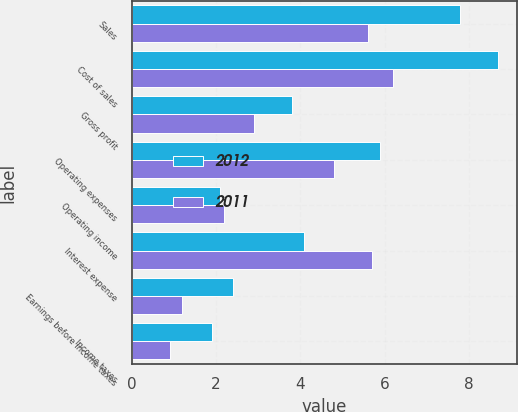Convert chart. <chart><loc_0><loc_0><loc_500><loc_500><stacked_bar_chart><ecel><fcel>Sales<fcel>Cost of sales<fcel>Gross profit<fcel>Operating expenses<fcel>Operating income<fcel>Interest expense<fcel>Earnings before income taxes<fcel>Income taxes<nl><fcel>2012<fcel>7.8<fcel>8.7<fcel>3.8<fcel>5.9<fcel>2.1<fcel>4.1<fcel>2.4<fcel>1.9<nl><fcel>2011<fcel>5.6<fcel>6.2<fcel>2.9<fcel>4.8<fcel>2.2<fcel>5.7<fcel>1.2<fcel>0.9<nl></chart> 